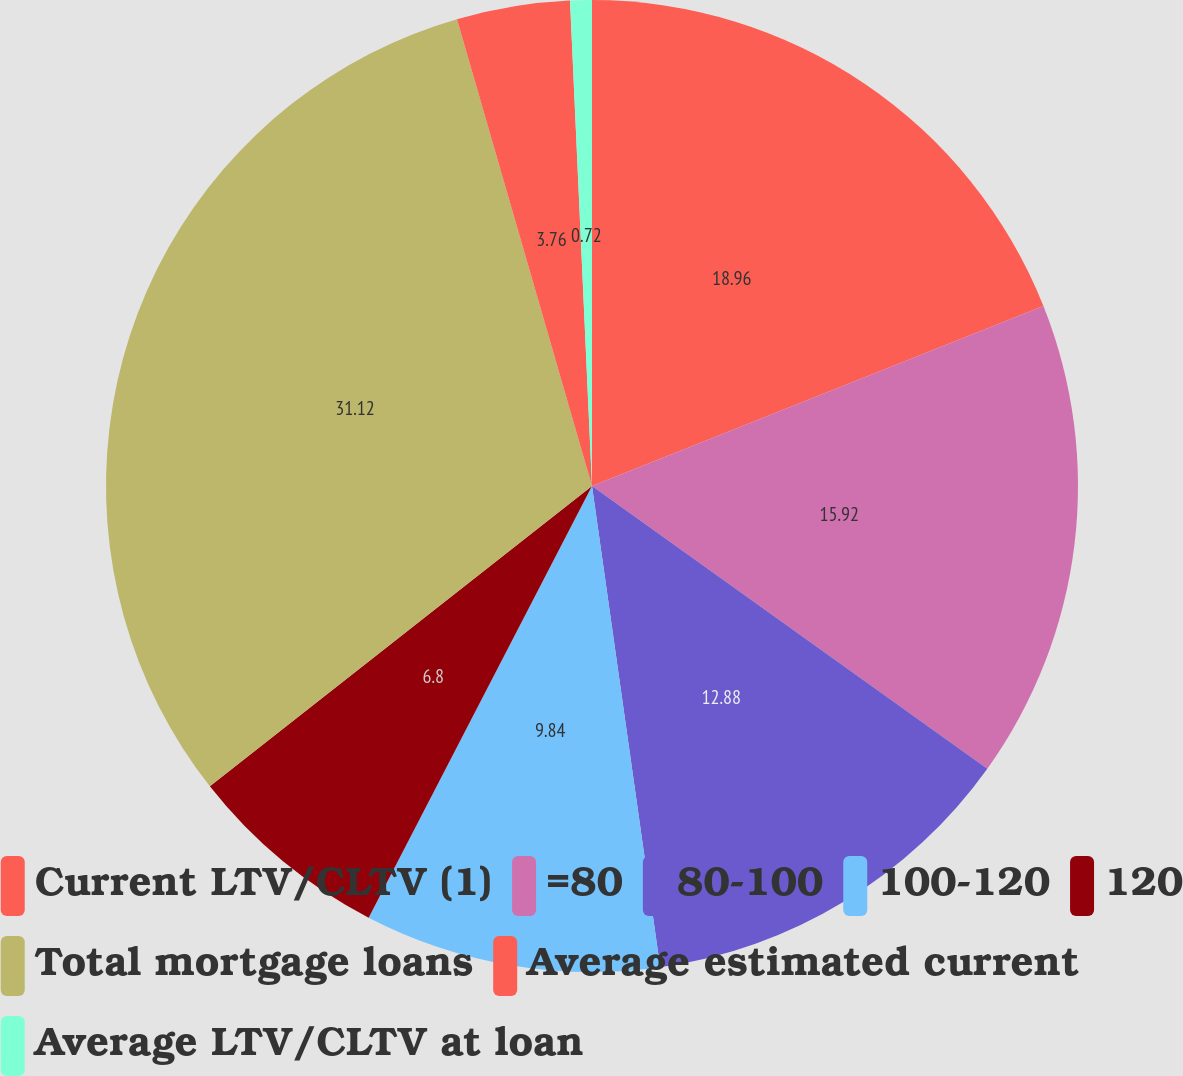Convert chart to OTSL. <chart><loc_0><loc_0><loc_500><loc_500><pie_chart><fcel>Current LTV/CLTV (1)<fcel>=80<fcel>80-100<fcel>100-120<fcel>120<fcel>Total mortgage loans<fcel>Average estimated current<fcel>Average LTV/CLTV at loan<nl><fcel>18.96%<fcel>15.92%<fcel>12.88%<fcel>9.84%<fcel>6.8%<fcel>31.12%<fcel>3.76%<fcel>0.72%<nl></chart> 